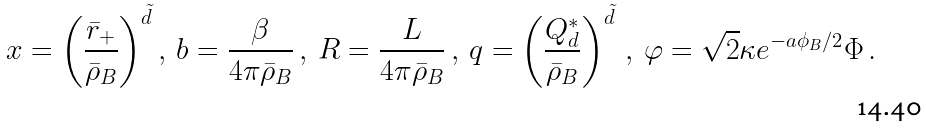Convert formula to latex. <formula><loc_0><loc_0><loc_500><loc_500>x = \left ( \frac { \bar { r } _ { + } } { \bar { \rho } _ { B } } \right ) ^ { \tilde { d } } , \, { b } = \frac { \beta } { 4 \pi \bar { \rho } _ { B } } \, , \, { R } = \frac { L } { 4 \pi \bar { \rho } _ { B } } \, , \, q = \left ( \frac { Q _ { d } ^ { * } } { \bar { \rho } _ { B } } \right ) ^ { \tilde { d } } \, , \, { \varphi } = \sqrt { 2 } \kappa e ^ { - a { \phi _ { B } } / 2 } \Phi \, .</formula> 